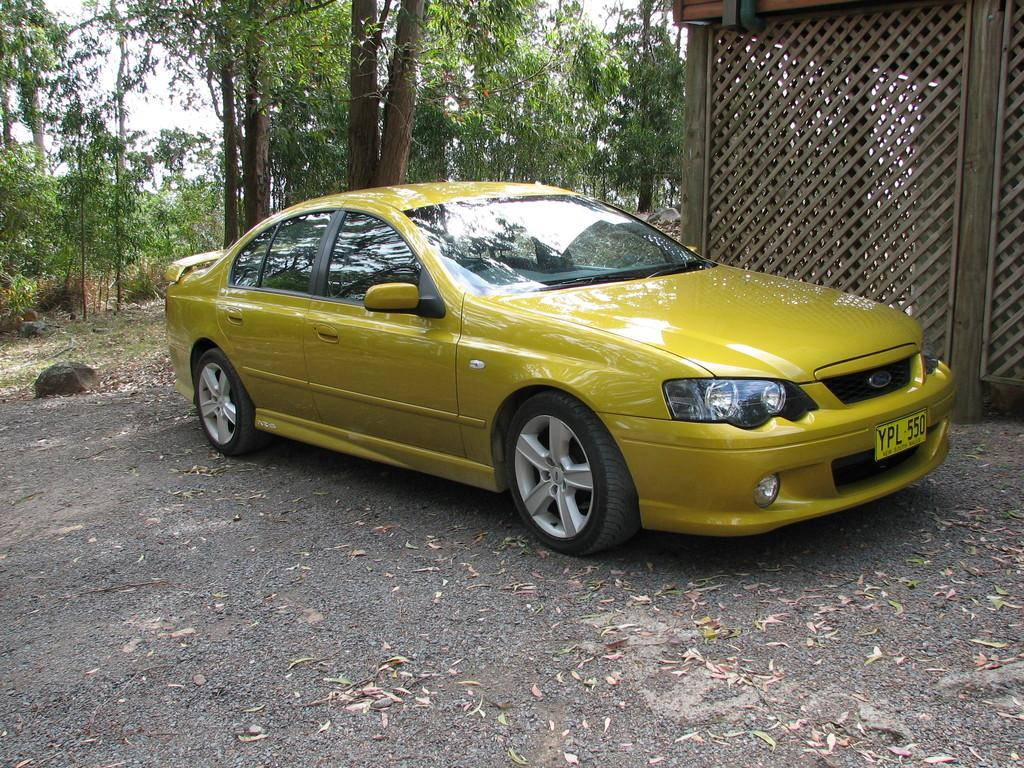What type of vehicle is in the image? There is a yellow color car in the image. What structure can be seen near the car? There is a wooden shed in the image. What can be seen in the background of the image? There are many trees and the sky visible in the background of the image. Can you see a pail hanging from the tree in the image? There is no pail hanging from a tree in the image. Is there an airplane flying in the sky in the image? The image does not show an airplane flying in the sky. 